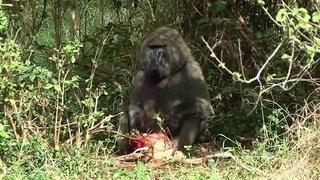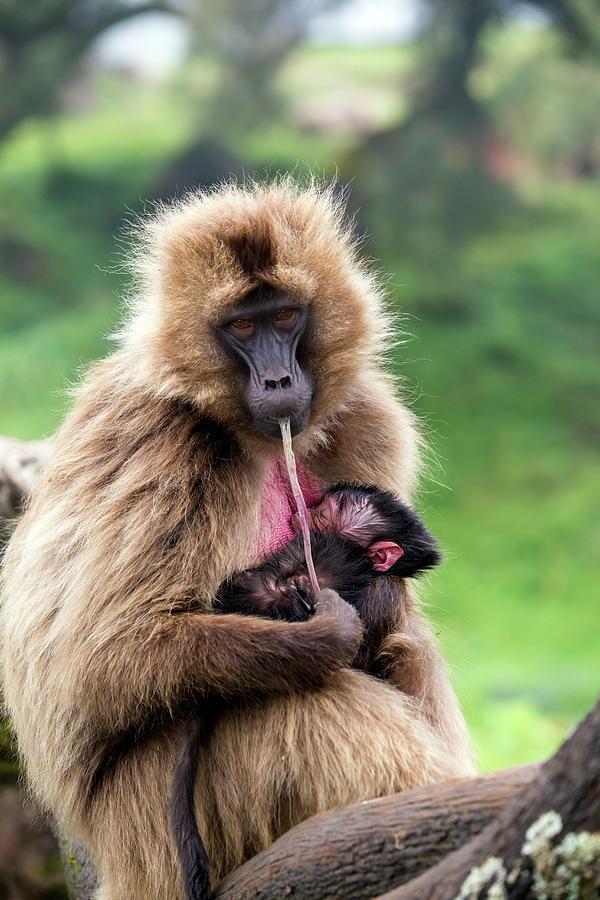The first image is the image on the left, the second image is the image on the right. Analyze the images presented: Is the assertion "A deceased animal is on the grass in front of a primate." valid? Answer yes or no. Yes. The first image is the image on the left, the second image is the image on the right. For the images shown, is this caption "An adult baboon is touching a dark-haired young baboon in one image." true? Answer yes or no. Yes. 